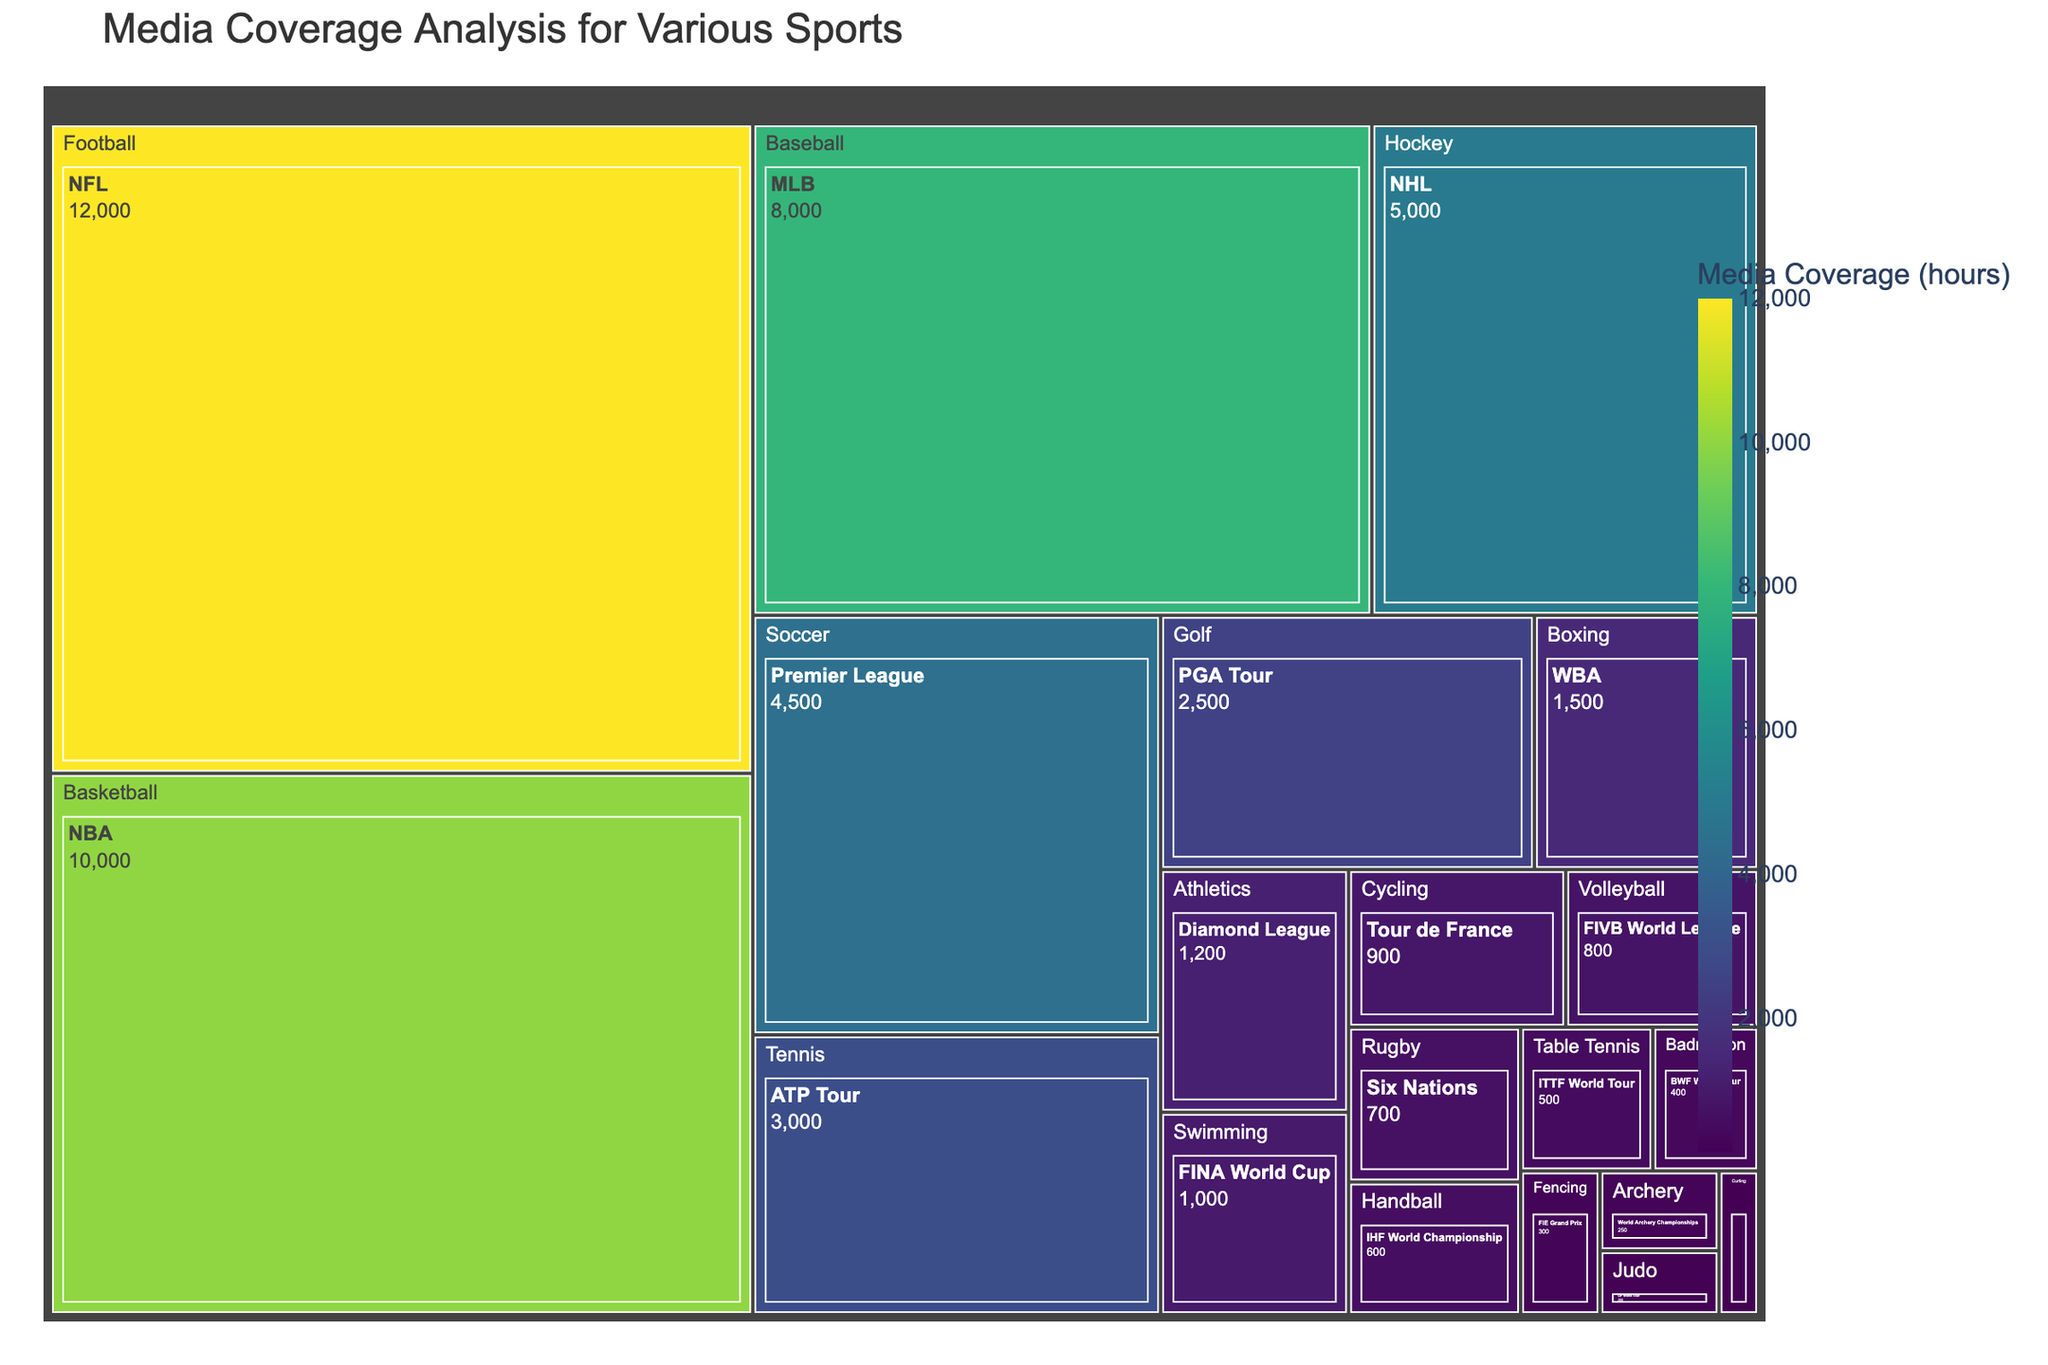What is the title of the treemap figure? Look at the top of the treemap to find the title. The title provides a brief description of the figure.
Answer: Media Coverage Analysis for Various Sports Which sport has the highest media coverage? Locate the largest section of the treemap, as the size corresponds to the media coverage. The sport with the largest section will have the highest media coverage.
Answer: Football How much media coverage does the NFL receive? Go to the section labeled "Football" and find the sub-section for "NFL." The value inside this sub-section is the media coverage for the NFL.
Answer: 12000 hours Which sport has more media coverage: Tennis or Golf? Find the sections labeled "Tennis" and "Golf," and compare their sizes and values. The sport with the larger section and higher value has more media coverage.
Answer: Tennis What is the media coverage difference between the NBA and MLB? Locate the sections for "Basketball" (NBA) and "Baseball" (MLB). Subtract the media coverage of MLB from that of NBA: 10000 - 8000 = 2000.
Answer: 2000 hours Which sport has the least media coverage? Identify the smallest section of the treemap because smaller sections correspond to lower media coverage.
Answer: Curling What is the combined media coverage for Athletics and Swimming? Locate the sections for "Athletics" (Diamond League) and "Swimming" (FINA World Cup). Add their values: 1200 + 1000 = 2200.
Answer: 2200 hours Is the media coverage for Boxing greater than Badminton? Compare the sizes and values of the sections for "Boxing" (WBA) and "Badminton" (BWF World Tour). The sport with the larger section and higher value has greater media coverage.
Answer: Yes, Boxing has greater media coverage How does the media coverage for soccer (Premier League) compare to hockey (NHL)? Locate the sections for "Soccer" (Premier League) and "Hockey" (NHL). Compare their sizes and values to see which has more media coverage.
Answer: Soccer has less media coverage than Hockey What is the average media coverage of the top three sports? Identify the top three sports by media coverage (Football, Basketball, and Baseball). Add their values and divide by three: (12000 + 10000 + 8000) / 3 = 10,000.
Answer: 10000 hours 